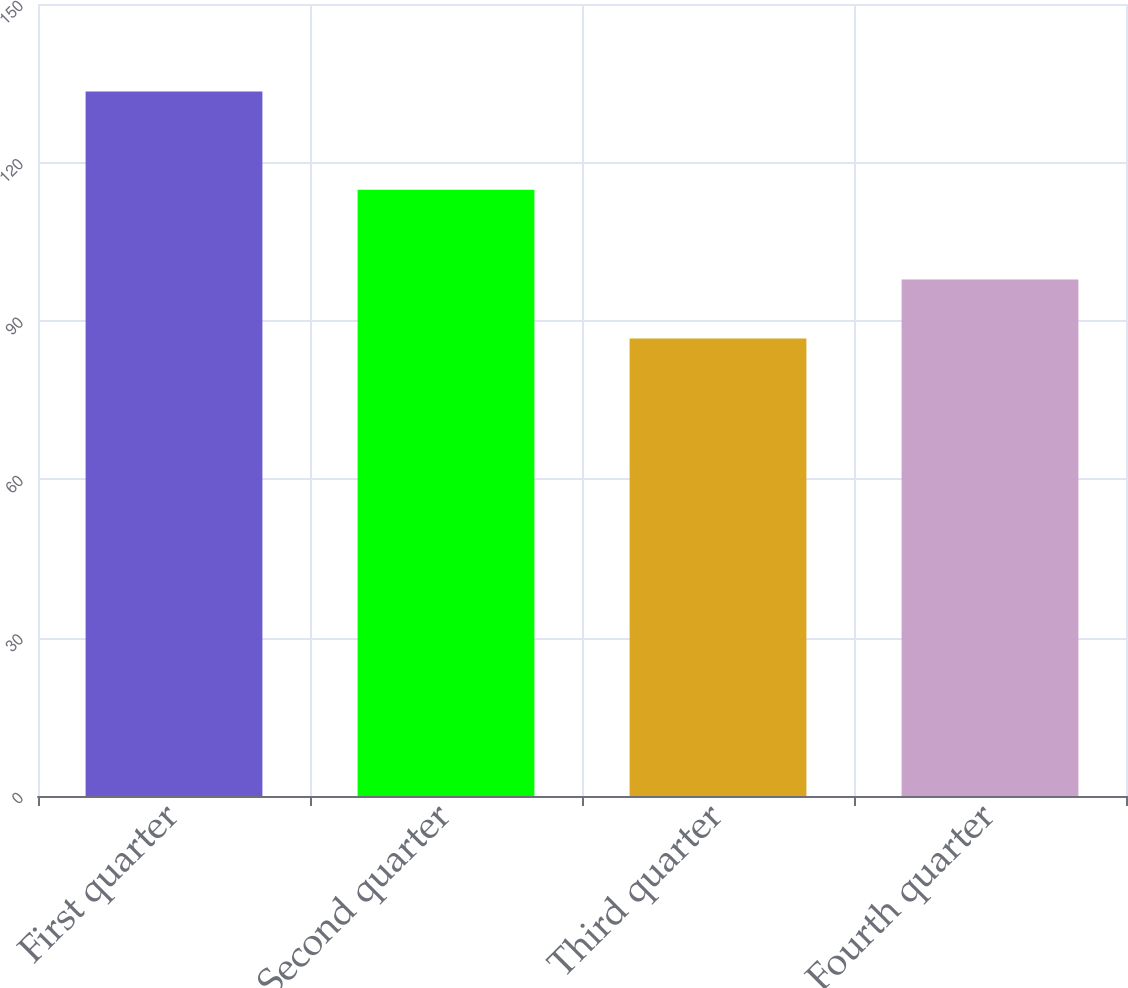<chart> <loc_0><loc_0><loc_500><loc_500><bar_chart><fcel>First quarter<fcel>Second quarter<fcel>Third quarter<fcel>Fourth quarter<nl><fcel>133.43<fcel>114.8<fcel>86.65<fcel>97.8<nl></chart> 